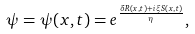<formula> <loc_0><loc_0><loc_500><loc_500>\psi = \psi ( x , t ) = e ^ { \frac { \delta R ( x , t ) + i \xi S ( x , t ) } { \eta } } ,</formula> 